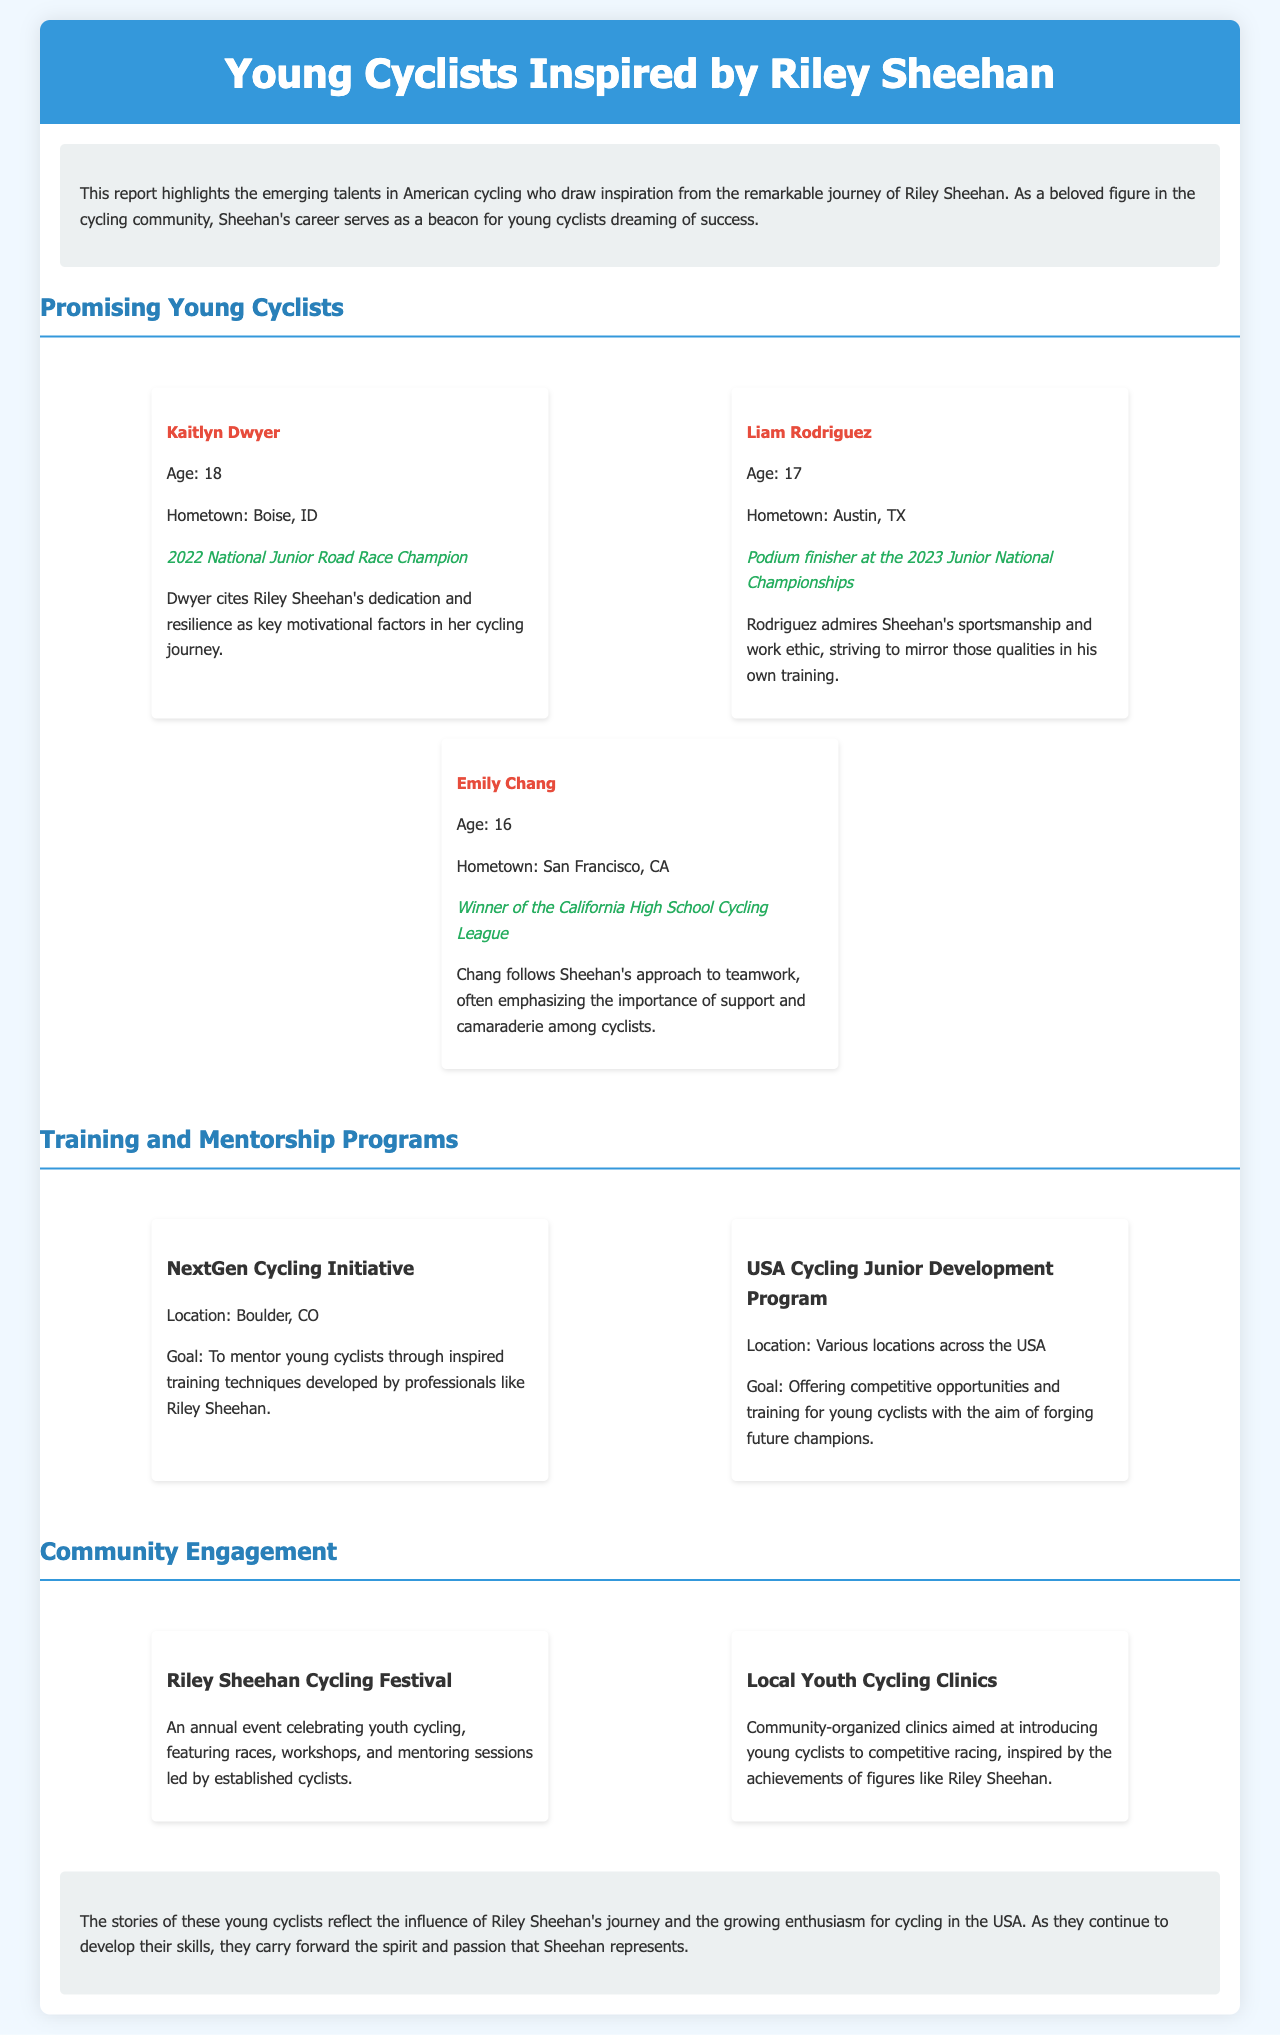What is the age of Kaitlyn Dwyer? Kaitlyn Dwyer is mentioned as being 18 years old in the document.
Answer: 18 Where is Liam Rodriguez from? The document states that Liam Rodriguez hails from Austin, TX.
Answer: Austin, TX What is Emily Chang's notable achievement? Emily Chang is recognized as the Winner of the California High School Cycling League in the document.
Answer: Winner of the California High School Cycling League Which program is located in Boulder, CO? The program “NextGen Cycling Initiative” is specified to be located in Boulder, CO.
Answer: NextGen Cycling Initiative What is the goal of the USA Cycling Junior Development Program? The document describes its goal as offering competitive opportunities and training for young cyclists.
Answer: Competitive opportunities and training How many promising young cyclists are highlighted in the report? The report features three promising young cyclists.
Answer: Three What is celebrated at the Riley Sheehan Cycling Festival? It is an annual event celebrating youth cycling, as noted in the document.
Answer: Youth cycling What is the focus of local youth cycling clinics? The clinics aim to introduce young cyclists to competitive racing.
Answer: Competitive racing Which cyclist mentioned views Riley Sheehan as a role model? All three cyclists highlight Sheehan's influence, but especially Kaitlyn Dwyer cites Sheehan as a motivational factor.
Answer: Kaitlyn Dwyer 